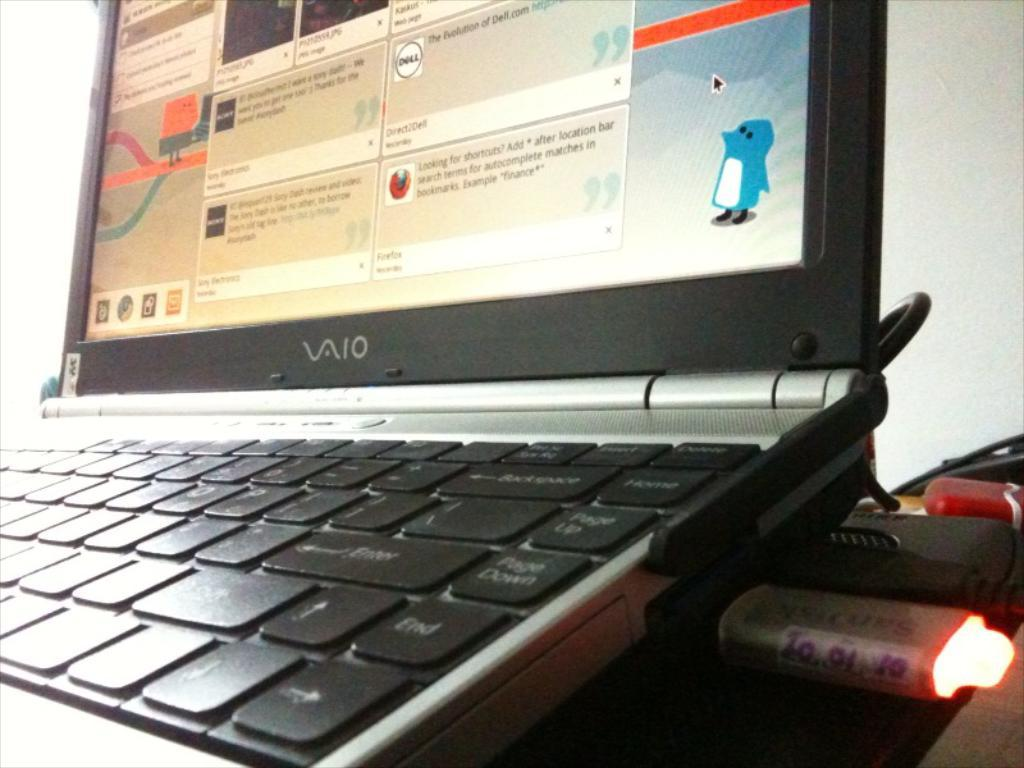<image>
Create a compact narrative representing the image presented. a vaio laptop is open and turned on 